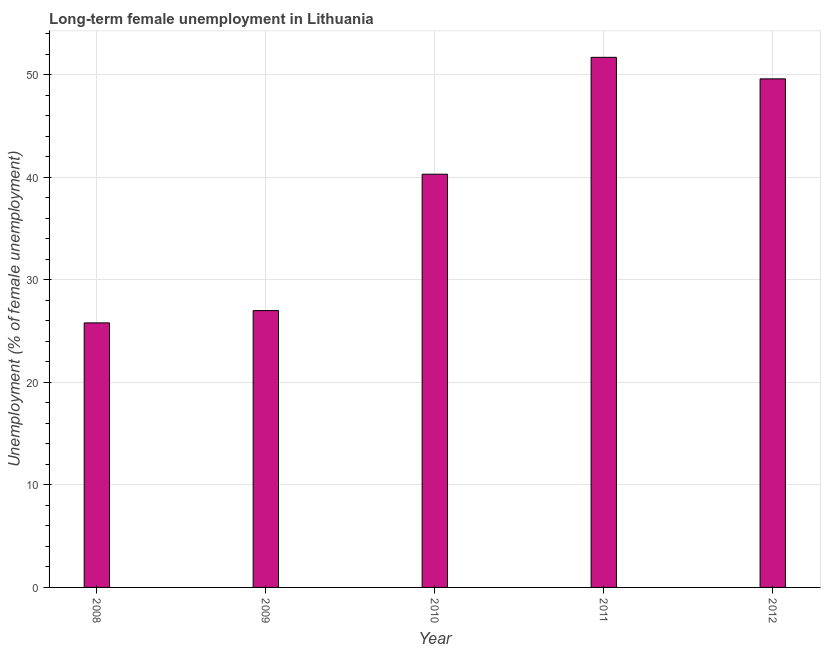Does the graph contain any zero values?
Provide a short and direct response. No. Does the graph contain grids?
Ensure brevity in your answer.  Yes. What is the title of the graph?
Give a very brief answer. Long-term female unemployment in Lithuania. What is the label or title of the Y-axis?
Provide a short and direct response. Unemployment (% of female unemployment). What is the long-term female unemployment in 2011?
Provide a short and direct response. 51.7. Across all years, what is the maximum long-term female unemployment?
Your answer should be compact. 51.7. Across all years, what is the minimum long-term female unemployment?
Your answer should be very brief. 25.8. What is the sum of the long-term female unemployment?
Make the answer very short. 194.4. What is the average long-term female unemployment per year?
Provide a short and direct response. 38.88. What is the median long-term female unemployment?
Make the answer very short. 40.3. In how many years, is the long-term female unemployment greater than 16 %?
Offer a very short reply. 5. What is the ratio of the long-term female unemployment in 2009 to that in 2010?
Make the answer very short. 0.67. Is the long-term female unemployment in 2009 less than that in 2011?
Keep it short and to the point. Yes. Is the difference between the long-term female unemployment in 2008 and 2012 greater than the difference between any two years?
Offer a very short reply. No. What is the difference between the highest and the lowest long-term female unemployment?
Give a very brief answer. 25.9. What is the difference between two consecutive major ticks on the Y-axis?
Give a very brief answer. 10. What is the Unemployment (% of female unemployment) in 2008?
Your response must be concise. 25.8. What is the Unemployment (% of female unemployment) of 2009?
Your response must be concise. 27. What is the Unemployment (% of female unemployment) of 2010?
Your answer should be very brief. 40.3. What is the Unemployment (% of female unemployment) of 2011?
Ensure brevity in your answer.  51.7. What is the Unemployment (% of female unemployment) in 2012?
Your answer should be very brief. 49.6. What is the difference between the Unemployment (% of female unemployment) in 2008 and 2009?
Your answer should be very brief. -1.2. What is the difference between the Unemployment (% of female unemployment) in 2008 and 2011?
Offer a very short reply. -25.9. What is the difference between the Unemployment (% of female unemployment) in 2008 and 2012?
Your answer should be compact. -23.8. What is the difference between the Unemployment (% of female unemployment) in 2009 and 2010?
Offer a terse response. -13.3. What is the difference between the Unemployment (% of female unemployment) in 2009 and 2011?
Your answer should be very brief. -24.7. What is the difference between the Unemployment (% of female unemployment) in 2009 and 2012?
Give a very brief answer. -22.6. What is the difference between the Unemployment (% of female unemployment) in 2010 and 2011?
Offer a very short reply. -11.4. What is the ratio of the Unemployment (% of female unemployment) in 2008 to that in 2009?
Give a very brief answer. 0.96. What is the ratio of the Unemployment (% of female unemployment) in 2008 to that in 2010?
Ensure brevity in your answer.  0.64. What is the ratio of the Unemployment (% of female unemployment) in 2008 to that in 2011?
Your response must be concise. 0.5. What is the ratio of the Unemployment (% of female unemployment) in 2008 to that in 2012?
Provide a short and direct response. 0.52. What is the ratio of the Unemployment (% of female unemployment) in 2009 to that in 2010?
Ensure brevity in your answer.  0.67. What is the ratio of the Unemployment (% of female unemployment) in 2009 to that in 2011?
Your answer should be very brief. 0.52. What is the ratio of the Unemployment (% of female unemployment) in 2009 to that in 2012?
Your answer should be compact. 0.54. What is the ratio of the Unemployment (% of female unemployment) in 2010 to that in 2011?
Keep it short and to the point. 0.78. What is the ratio of the Unemployment (% of female unemployment) in 2010 to that in 2012?
Offer a very short reply. 0.81. What is the ratio of the Unemployment (% of female unemployment) in 2011 to that in 2012?
Offer a very short reply. 1.04. 